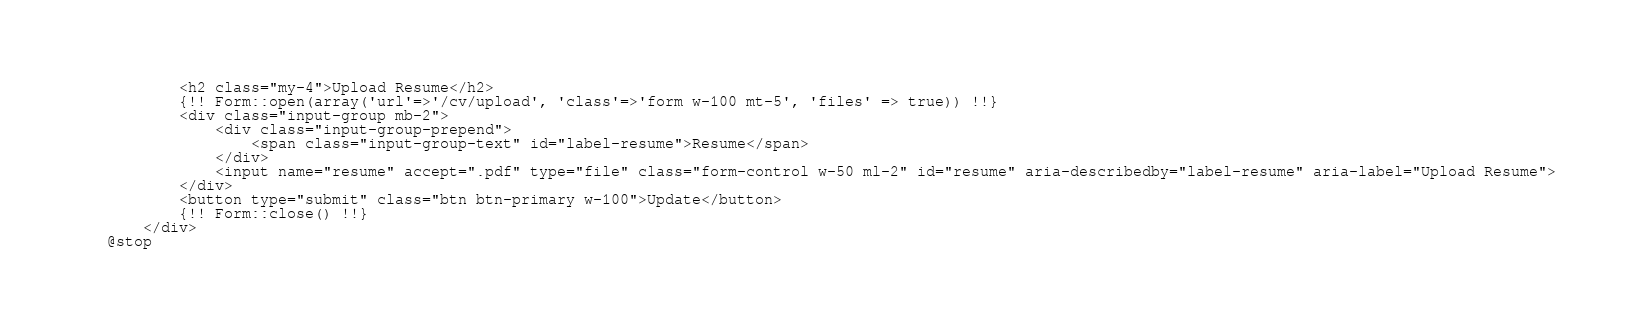Convert code to text. <code><loc_0><loc_0><loc_500><loc_500><_PHP_>        <h2 class="my-4">Upload Resume</h2>
        {!! Form::open(array('url'=>'/cv/upload', 'class'=>'form w-100 mt-5', 'files' => true)) !!}
        <div class="input-group mb-2">
            <div class="input-group-prepend">
                <span class="input-group-text" id="label-resume">Resume</span>
            </div>
            <input name="resume" accept=".pdf" type="file" class="form-control w-50 ml-2" id="resume" aria-describedby="label-resume" aria-label="Upload Resume">
        </div>
        <button type="submit" class="btn btn-primary w-100">Update</button>
        {!! Form::close() !!}
    </div>
@stop</code> 